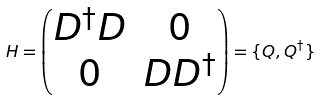<formula> <loc_0><loc_0><loc_500><loc_500>H = \begin{pmatrix} D ^ { \dagger } D & 0 \\ 0 & D D ^ { \dagger } \end{pmatrix} = \{ Q , Q ^ { \dagger } \}</formula> 